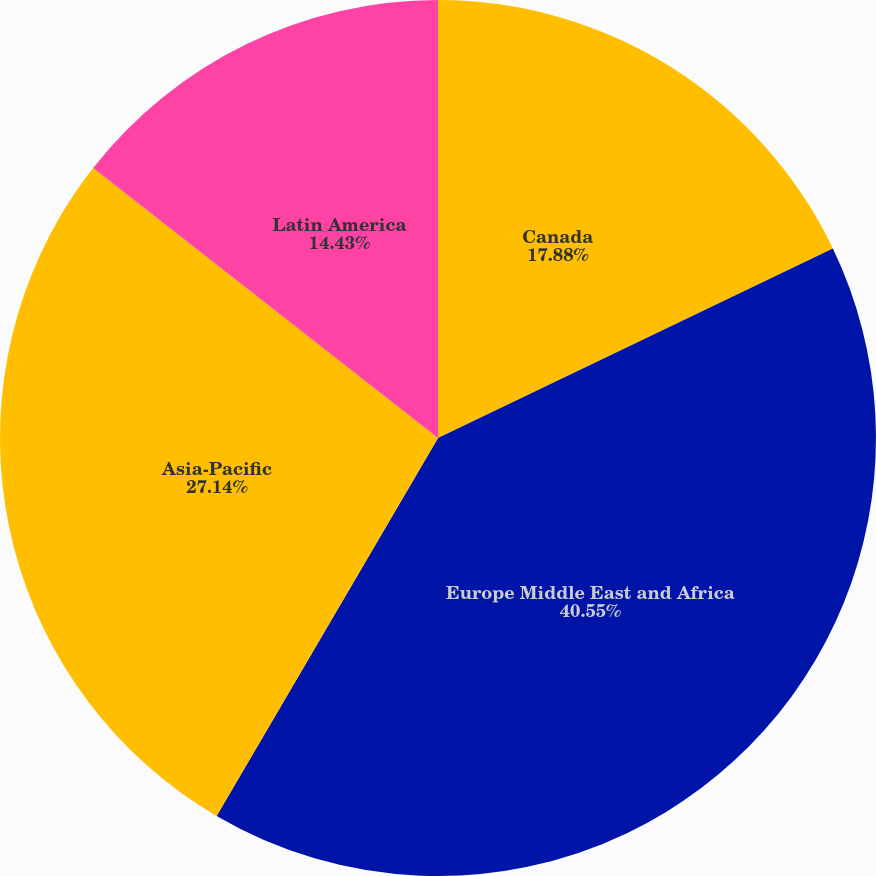Convert chart. <chart><loc_0><loc_0><loc_500><loc_500><pie_chart><fcel>Canada<fcel>Europe Middle East and Africa<fcel>Asia-Pacific<fcel>Latin America<nl><fcel>17.88%<fcel>40.56%<fcel>27.14%<fcel>14.43%<nl></chart> 